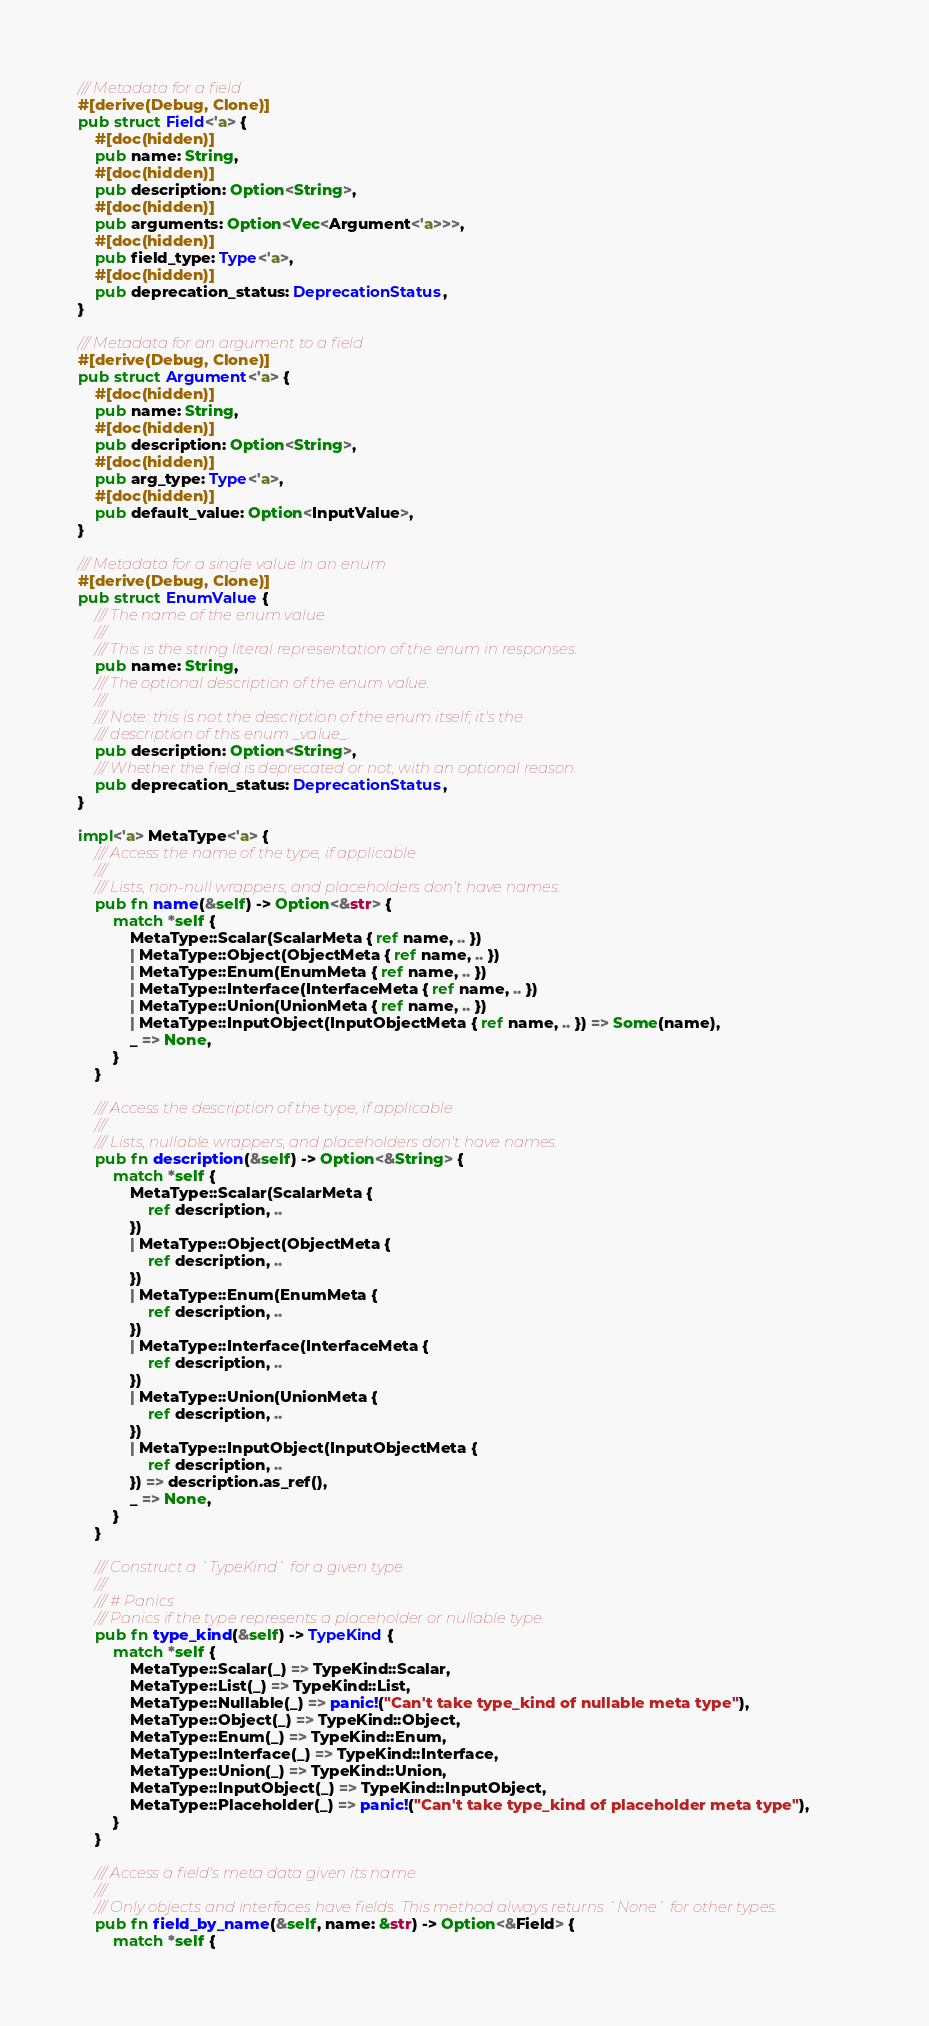Convert code to text. <code><loc_0><loc_0><loc_500><loc_500><_Rust_>
/// Metadata for a field
#[derive(Debug, Clone)]
pub struct Field<'a> {
    #[doc(hidden)]
    pub name: String,
    #[doc(hidden)]
    pub description: Option<String>,
    #[doc(hidden)]
    pub arguments: Option<Vec<Argument<'a>>>,
    #[doc(hidden)]
    pub field_type: Type<'a>,
    #[doc(hidden)]
    pub deprecation_status: DeprecationStatus,
}

/// Metadata for an argument to a field
#[derive(Debug, Clone)]
pub struct Argument<'a> {
    #[doc(hidden)]
    pub name: String,
    #[doc(hidden)]
    pub description: Option<String>,
    #[doc(hidden)]
    pub arg_type: Type<'a>,
    #[doc(hidden)]
    pub default_value: Option<InputValue>,
}

/// Metadata for a single value in an enum
#[derive(Debug, Clone)]
pub struct EnumValue {
    /// The name of the enum value
    ///
    /// This is the string literal representation of the enum in responses.
    pub name: String,
    /// The optional description of the enum value.
    ///
    /// Note: this is not the description of the enum itself; it's the
    /// description of this enum _value_.
    pub description: Option<String>,
    /// Whether the field is deprecated or not, with an optional reason.
    pub deprecation_status: DeprecationStatus,
}

impl<'a> MetaType<'a> {
    /// Access the name of the type, if applicable
    ///
    /// Lists, non-null wrappers, and placeholders don't have names.
    pub fn name(&self) -> Option<&str> {
        match *self {
            MetaType::Scalar(ScalarMeta { ref name, .. })
            | MetaType::Object(ObjectMeta { ref name, .. })
            | MetaType::Enum(EnumMeta { ref name, .. })
            | MetaType::Interface(InterfaceMeta { ref name, .. })
            | MetaType::Union(UnionMeta { ref name, .. })
            | MetaType::InputObject(InputObjectMeta { ref name, .. }) => Some(name),
            _ => None,
        }
    }

    /// Access the description of the type, if applicable
    ///
    /// Lists, nullable wrappers, and placeholders don't have names.
    pub fn description(&self) -> Option<&String> {
        match *self {
            MetaType::Scalar(ScalarMeta {
                ref description, ..
            })
            | MetaType::Object(ObjectMeta {
                ref description, ..
            })
            | MetaType::Enum(EnumMeta {
                ref description, ..
            })
            | MetaType::Interface(InterfaceMeta {
                ref description, ..
            })
            | MetaType::Union(UnionMeta {
                ref description, ..
            })
            | MetaType::InputObject(InputObjectMeta {
                ref description, ..
            }) => description.as_ref(),
            _ => None,
        }
    }

    /// Construct a `TypeKind` for a given type
    ///
    /// # Panics
    /// Panics if the type represents a placeholder or nullable type.
    pub fn type_kind(&self) -> TypeKind {
        match *self {
            MetaType::Scalar(_) => TypeKind::Scalar,
            MetaType::List(_) => TypeKind::List,
            MetaType::Nullable(_) => panic!("Can't take type_kind of nullable meta type"),
            MetaType::Object(_) => TypeKind::Object,
            MetaType::Enum(_) => TypeKind::Enum,
            MetaType::Interface(_) => TypeKind::Interface,
            MetaType::Union(_) => TypeKind::Union,
            MetaType::InputObject(_) => TypeKind::InputObject,
            MetaType::Placeholder(_) => panic!("Can't take type_kind of placeholder meta type"),
        }
    }

    /// Access a field's meta data given its name
    ///
    /// Only objects and interfaces have fields. This method always returns `None` for other types.
    pub fn field_by_name(&self, name: &str) -> Option<&Field> {
        match *self {</code> 